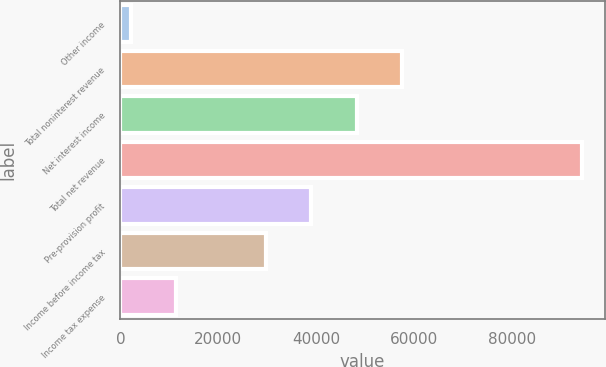Convert chart to OTSL. <chart><loc_0><loc_0><loc_500><loc_500><bar_chart><fcel>Other income<fcel>Total noninterest revenue<fcel>Net interest income<fcel>Total net revenue<fcel>Pre-provision profit<fcel>Income before income tax<fcel>Income tax expense<nl><fcel>2106<fcel>57421.7<fcel>48211.8<fcel>94205<fcel>39001.9<fcel>29792<fcel>11315.9<nl></chart> 